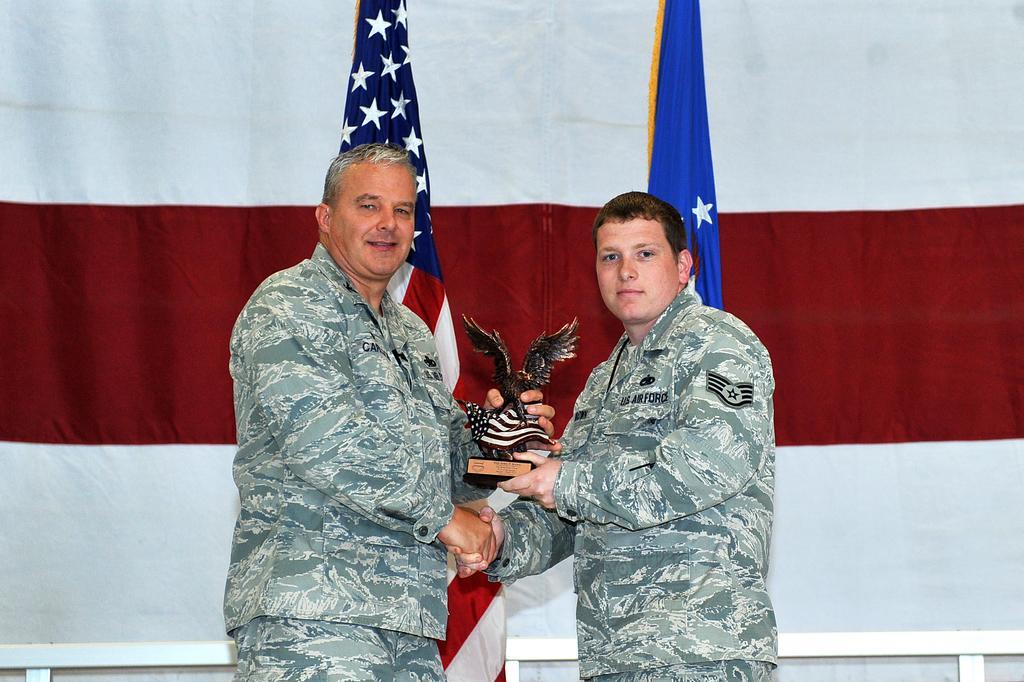Please provide a concise description of this image. In this picture there are two people standing and holding a statue. In the background of the image we can see flags, white object and colorful cloth. 